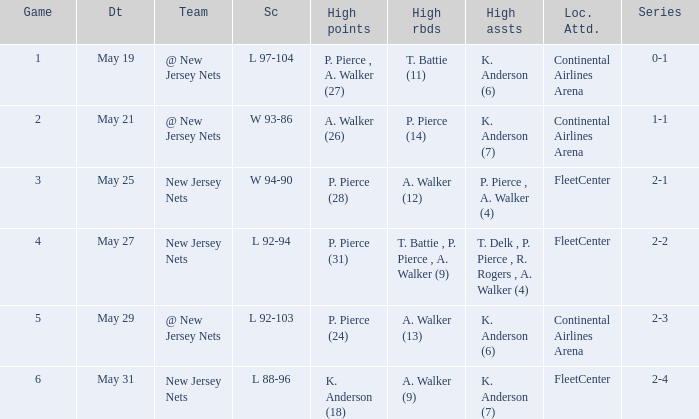What was the highest assists for game 3? P. Pierce , A. Walker (4). 